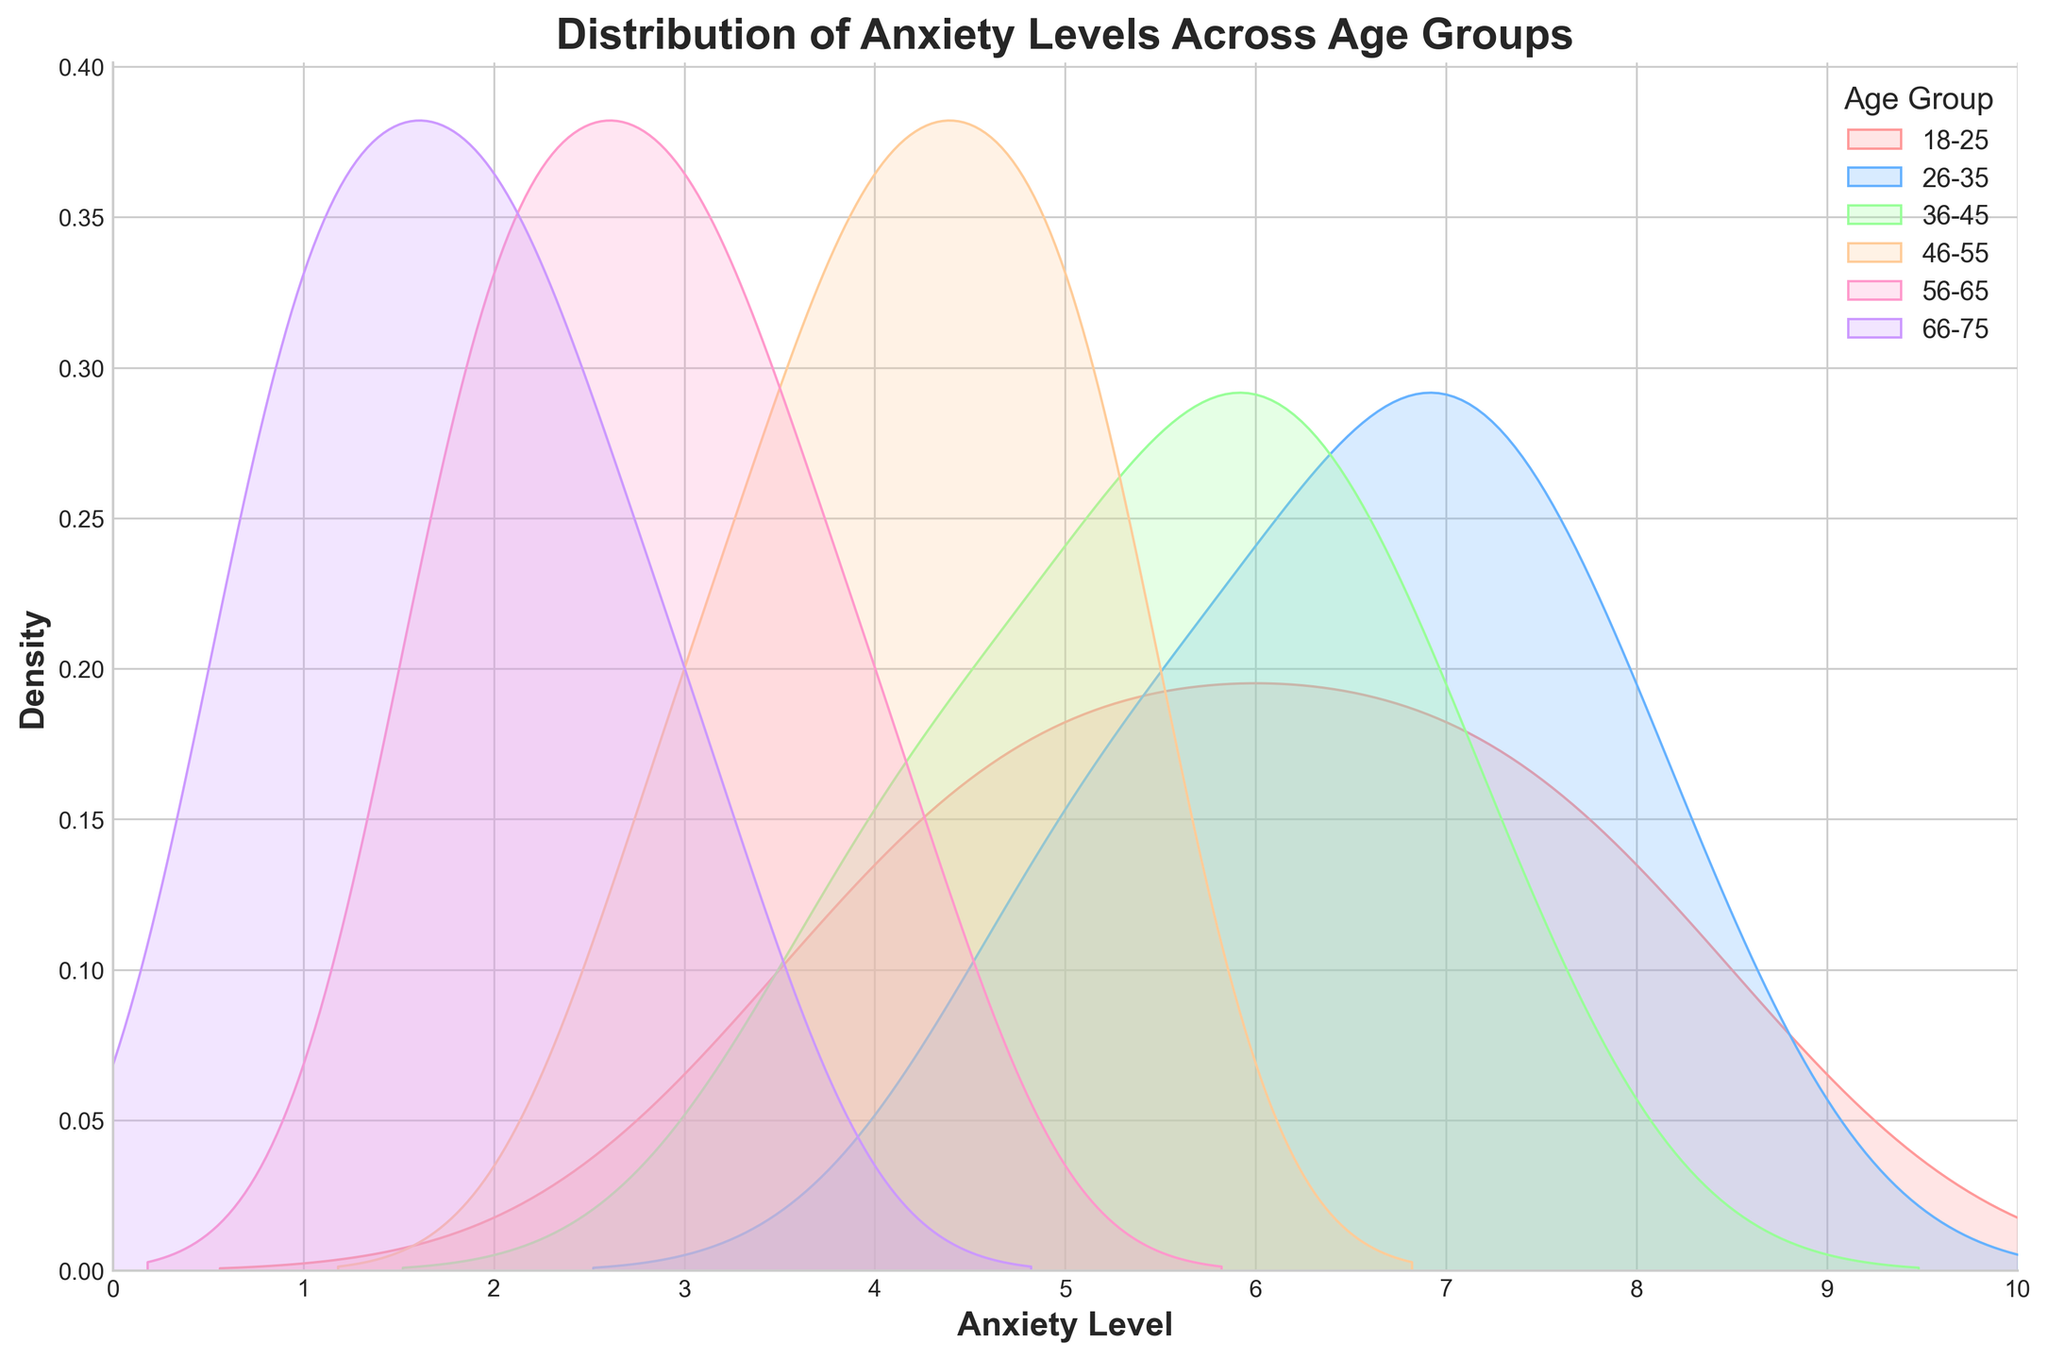What's the title of the plot? The title is displayed at the top of the plot and typically summarizes the content or focus of the plot. It reads "Distribution of Anxiety Levels Across Age Groups".
Answer: Distribution of Anxiety Levels Across Age Groups What does the x-axis represent? The x-axis is labeled with "Anxiety Level", indicating that it represents different levels of anxiety measured on this scale.
Answer: Anxiety Level In which age group does the anxiety level have the highest density? To determine this, observe the peaks of the density curves. The 18-25 age group has the highest density peak among all shown.
Answer: 18-25 How many age groups are represented in the plot? By looking at the legend, we can count the number of different age groups listed. There are six age groups represented in this plot.
Answer: Six Which age group has the lowest density in anxiety levels? By observing the density curves, the age group 66-75 has the lowest density peaks in the graph.
Answer: 66-75 What color represents the 26-35 age group in the plot? According to the legend, each age group is assigned a different color. The 26-35 age group is represented by a blue shade color.
Answer: Blue How does the anxiety level density differ between the 18-25 and 56-65 age groups? By comparing the density curves, the 18-25 age group has higher peaks and a higher density overall compared to the 56-65 age group, which shows low, more spread-out densities.
Answer: The 18-25 age group has higher and more concentrated density peaks than the 56-65 age group Do any age groups overlap in their anxiety level densities? By examining the density curves, we can see that some curves overlap, indicating that some age groups have common anxiety levels. For instance, 26-35 and 36-45 age groups show overlapping densities around levels 5-7.
Answer: Yes Which age group shows the most spread-out distribution of anxiety levels? By observing the width and spread of the density curves, the 36-45 age group appears to have one of the more spread-out distributions, suggesting variability in anxiety levels.
Answer: 36-45 Which age groups have density curves that are most similar? Comparing the shapes and peaks of the density curves, the 56-65 and 66-75 age groups have quite similar density distributions.
Answer: 56-65 and 66-75 